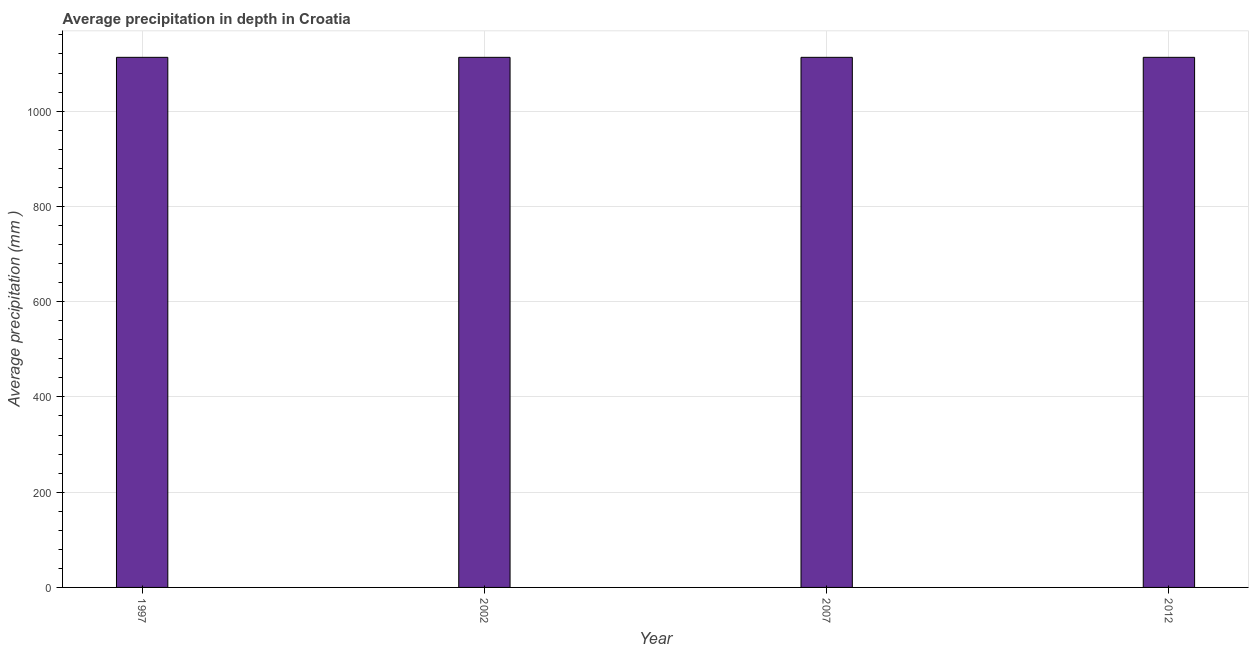Does the graph contain grids?
Keep it short and to the point. Yes. What is the title of the graph?
Offer a terse response. Average precipitation in depth in Croatia. What is the label or title of the Y-axis?
Provide a short and direct response. Average precipitation (mm ). What is the average precipitation in depth in 2002?
Your answer should be compact. 1113. Across all years, what is the maximum average precipitation in depth?
Your response must be concise. 1113. Across all years, what is the minimum average precipitation in depth?
Provide a short and direct response. 1113. What is the sum of the average precipitation in depth?
Your answer should be very brief. 4452. What is the average average precipitation in depth per year?
Your response must be concise. 1113. What is the median average precipitation in depth?
Provide a succinct answer. 1113. What is the ratio of the average precipitation in depth in 1997 to that in 2002?
Provide a short and direct response. 1. Is the difference between the average precipitation in depth in 2007 and 2012 greater than the difference between any two years?
Keep it short and to the point. Yes. What is the difference between the highest and the second highest average precipitation in depth?
Keep it short and to the point. 0. Is the sum of the average precipitation in depth in 1997 and 2007 greater than the maximum average precipitation in depth across all years?
Your answer should be compact. Yes. What is the difference between the highest and the lowest average precipitation in depth?
Give a very brief answer. 0. In how many years, is the average precipitation in depth greater than the average average precipitation in depth taken over all years?
Provide a succinct answer. 0. How many bars are there?
Provide a short and direct response. 4. Are all the bars in the graph horizontal?
Provide a short and direct response. No. How many years are there in the graph?
Your answer should be very brief. 4. What is the difference between two consecutive major ticks on the Y-axis?
Provide a short and direct response. 200. Are the values on the major ticks of Y-axis written in scientific E-notation?
Make the answer very short. No. What is the Average precipitation (mm ) of 1997?
Ensure brevity in your answer.  1113. What is the Average precipitation (mm ) of 2002?
Offer a terse response. 1113. What is the Average precipitation (mm ) of 2007?
Your answer should be compact. 1113. What is the Average precipitation (mm ) of 2012?
Provide a short and direct response. 1113. What is the difference between the Average precipitation (mm ) in 1997 and 2007?
Offer a terse response. 0. What is the difference between the Average precipitation (mm ) in 2002 and 2007?
Provide a short and direct response. 0. What is the difference between the Average precipitation (mm ) in 2002 and 2012?
Your answer should be very brief. 0. What is the ratio of the Average precipitation (mm ) in 1997 to that in 2002?
Your answer should be compact. 1. What is the ratio of the Average precipitation (mm ) in 2007 to that in 2012?
Your answer should be compact. 1. 